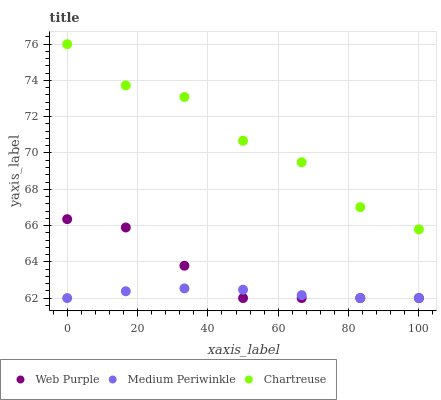Does Medium Periwinkle have the minimum area under the curve?
Answer yes or no. Yes. Does Chartreuse have the maximum area under the curve?
Answer yes or no. Yes. Does Chartreuse have the minimum area under the curve?
Answer yes or no. No. Does Medium Periwinkle have the maximum area under the curve?
Answer yes or no. No. Is Medium Periwinkle the smoothest?
Answer yes or no. Yes. Is Chartreuse the roughest?
Answer yes or no. Yes. Is Chartreuse the smoothest?
Answer yes or no. No. Is Medium Periwinkle the roughest?
Answer yes or no. No. Does Web Purple have the lowest value?
Answer yes or no. Yes. Does Chartreuse have the lowest value?
Answer yes or no. No. Does Chartreuse have the highest value?
Answer yes or no. Yes. Does Medium Periwinkle have the highest value?
Answer yes or no. No. Is Web Purple less than Chartreuse?
Answer yes or no. Yes. Is Chartreuse greater than Web Purple?
Answer yes or no. Yes. Does Web Purple intersect Medium Periwinkle?
Answer yes or no. Yes. Is Web Purple less than Medium Periwinkle?
Answer yes or no. No. Is Web Purple greater than Medium Periwinkle?
Answer yes or no. No. Does Web Purple intersect Chartreuse?
Answer yes or no. No. 